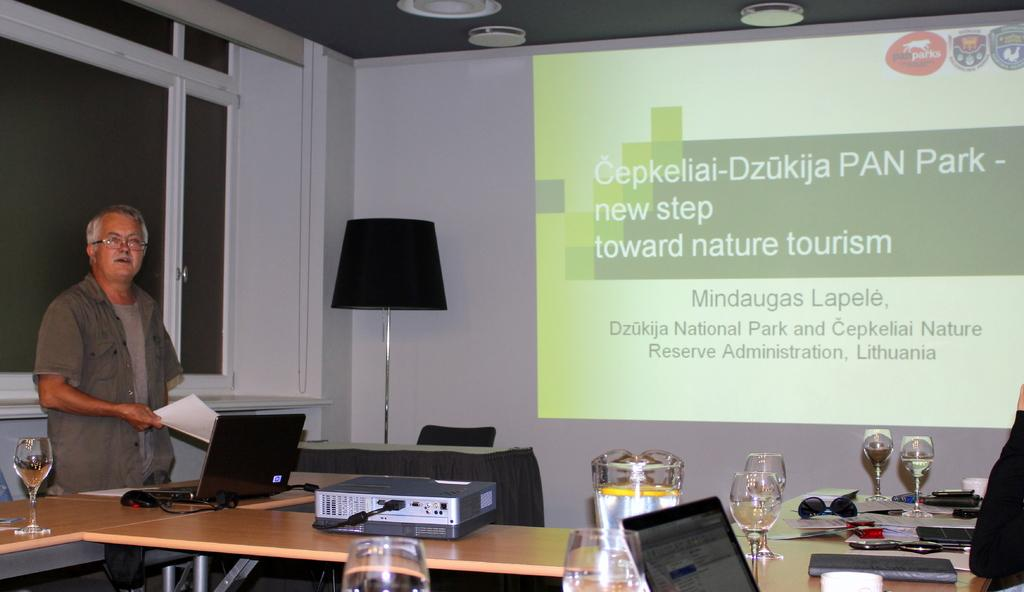<image>
Summarize the visual content of the image. A projected image contains the words nature and tourism, among others. 